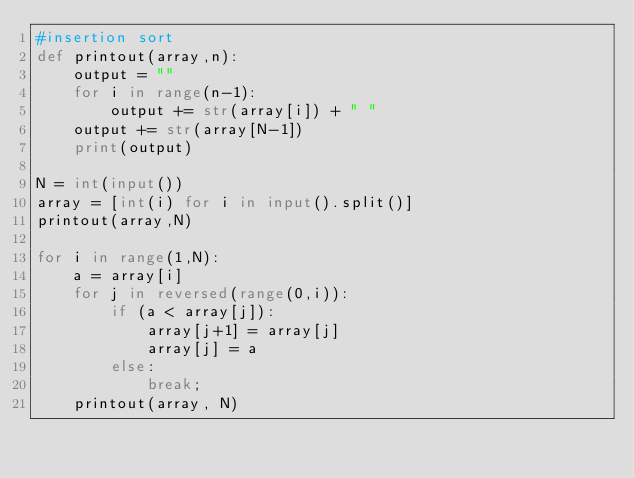<code> <loc_0><loc_0><loc_500><loc_500><_Python_>#insertion sort
def printout(array,n):
    output = ""
    for i in range(n-1):
        output += str(array[i]) + " "
    output += str(array[N-1])
    print(output)

N = int(input())
array = [int(i) for i in input().split()]
printout(array,N)

for i in range(1,N):
    a = array[i]
    for j in reversed(range(0,i)):
        if (a < array[j]):
            array[j+1] = array[j]
            array[j] = a
        else:
            break;
    printout(array, N)
</code> 